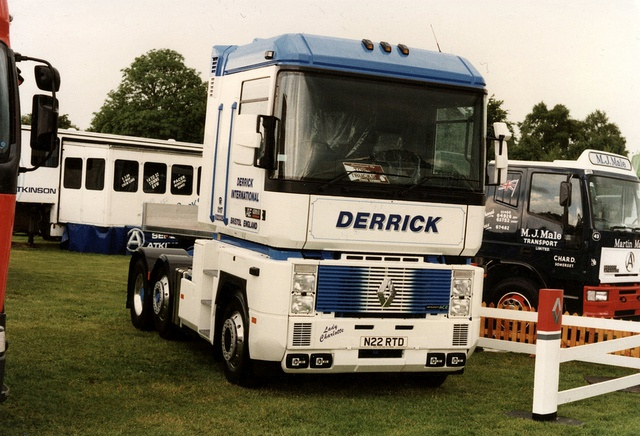Describe the objects in this image and their specific colors. I can see truck in brown, black, beige, tan, and darkgray tones, truck in brown, black, gray, ivory, and darkgray tones, truck in brown, black, lightgray, tan, and gray tones, and truck in brown, black, ivory, and darkgreen tones in this image. 